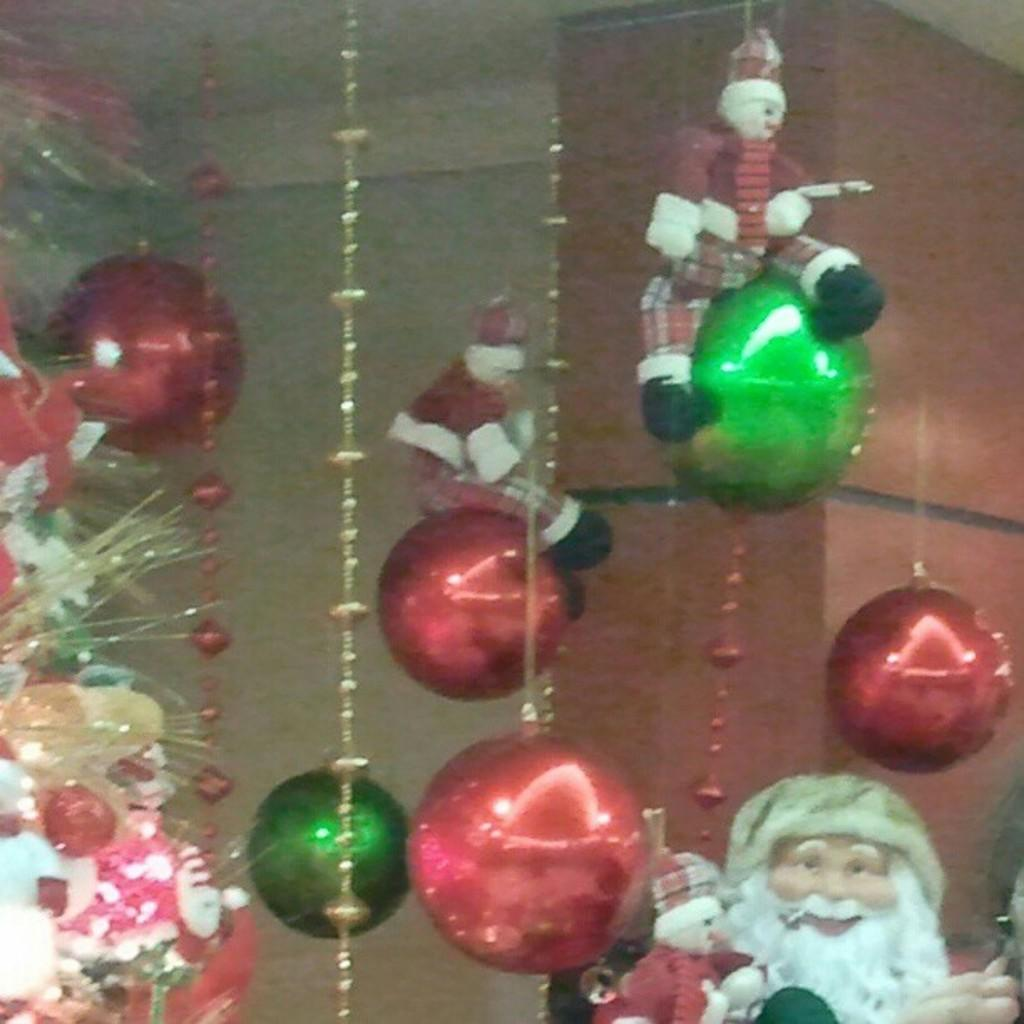What type of objects are hanging in the image? There are soft toys hanging in the image. What other decorative items can be seen in the image? There are decorative balls in the image. What figure is present in the image? There is a Santa Claus statue in the image. What type of plants are visible in the image? There are flowers on the side in the image. Can you see any honey dripping from the soft toys in the image? There is no honey present in the image, and the soft toys are not depicted as dripping any substance. 